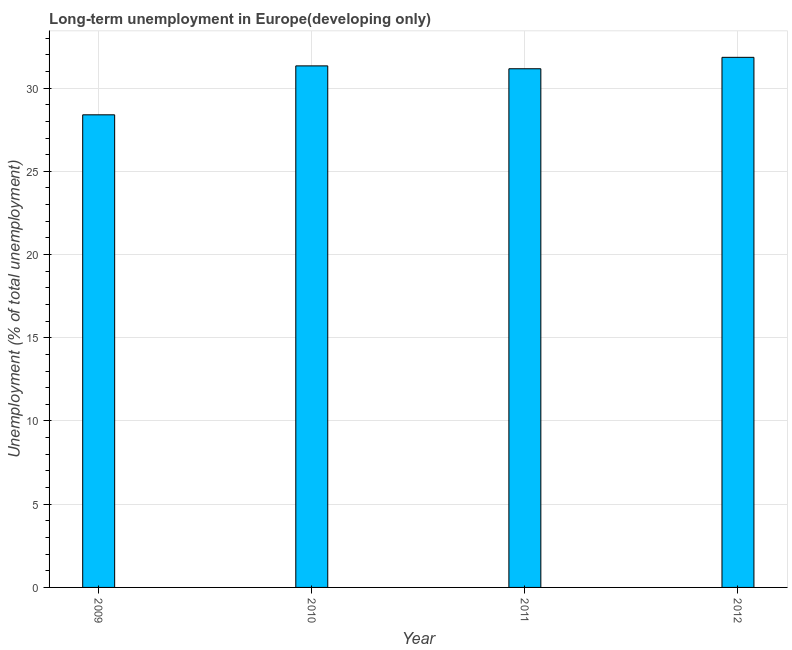What is the title of the graph?
Offer a very short reply. Long-term unemployment in Europe(developing only). What is the label or title of the Y-axis?
Provide a succinct answer. Unemployment (% of total unemployment). What is the long-term unemployment in 2009?
Your response must be concise. 28.4. Across all years, what is the maximum long-term unemployment?
Give a very brief answer. 31.85. Across all years, what is the minimum long-term unemployment?
Give a very brief answer. 28.4. In which year was the long-term unemployment minimum?
Offer a terse response. 2009. What is the sum of the long-term unemployment?
Your answer should be very brief. 122.74. What is the difference between the long-term unemployment in 2009 and 2012?
Your answer should be very brief. -3.45. What is the average long-term unemployment per year?
Ensure brevity in your answer.  30.69. What is the median long-term unemployment?
Ensure brevity in your answer.  31.25. Do a majority of the years between 2011 and 2012 (inclusive) have long-term unemployment greater than 25 %?
Offer a terse response. Yes. What is the ratio of the long-term unemployment in 2009 to that in 2010?
Ensure brevity in your answer.  0.91. What is the difference between the highest and the second highest long-term unemployment?
Offer a very short reply. 0.51. Is the sum of the long-term unemployment in 2009 and 2010 greater than the maximum long-term unemployment across all years?
Ensure brevity in your answer.  Yes. What is the difference between the highest and the lowest long-term unemployment?
Your response must be concise. 3.45. How many bars are there?
Offer a very short reply. 4. How many years are there in the graph?
Offer a very short reply. 4. What is the difference between two consecutive major ticks on the Y-axis?
Keep it short and to the point. 5. What is the Unemployment (% of total unemployment) of 2009?
Your answer should be compact. 28.4. What is the Unemployment (% of total unemployment) of 2010?
Ensure brevity in your answer.  31.34. What is the Unemployment (% of total unemployment) in 2011?
Your answer should be very brief. 31.16. What is the Unemployment (% of total unemployment) of 2012?
Your answer should be very brief. 31.85. What is the difference between the Unemployment (% of total unemployment) in 2009 and 2010?
Give a very brief answer. -2.94. What is the difference between the Unemployment (% of total unemployment) in 2009 and 2011?
Offer a very short reply. -2.77. What is the difference between the Unemployment (% of total unemployment) in 2009 and 2012?
Offer a very short reply. -3.45. What is the difference between the Unemployment (% of total unemployment) in 2010 and 2011?
Your answer should be compact. 0.17. What is the difference between the Unemployment (% of total unemployment) in 2010 and 2012?
Ensure brevity in your answer.  -0.51. What is the difference between the Unemployment (% of total unemployment) in 2011 and 2012?
Your answer should be very brief. -0.69. What is the ratio of the Unemployment (% of total unemployment) in 2009 to that in 2010?
Make the answer very short. 0.91. What is the ratio of the Unemployment (% of total unemployment) in 2009 to that in 2011?
Ensure brevity in your answer.  0.91. What is the ratio of the Unemployment (% of total unemployment) in 2009 to that in 2012?
Provide a succinct answer. 0.89. What is the ratio of the Unemployment (% of total unemployment) in 2010 to that in 2011?
Your answer should be compact. 1.01. What is the ratio of the Unemployment (% of total unemployment) in 2010 to that in 2012?
Your answer should be very brief. 0.98. What is the ratio of the Unemployment (% of total unemployment) in 2011 to that in 2012?
Offer a very short reply. 0.98. 